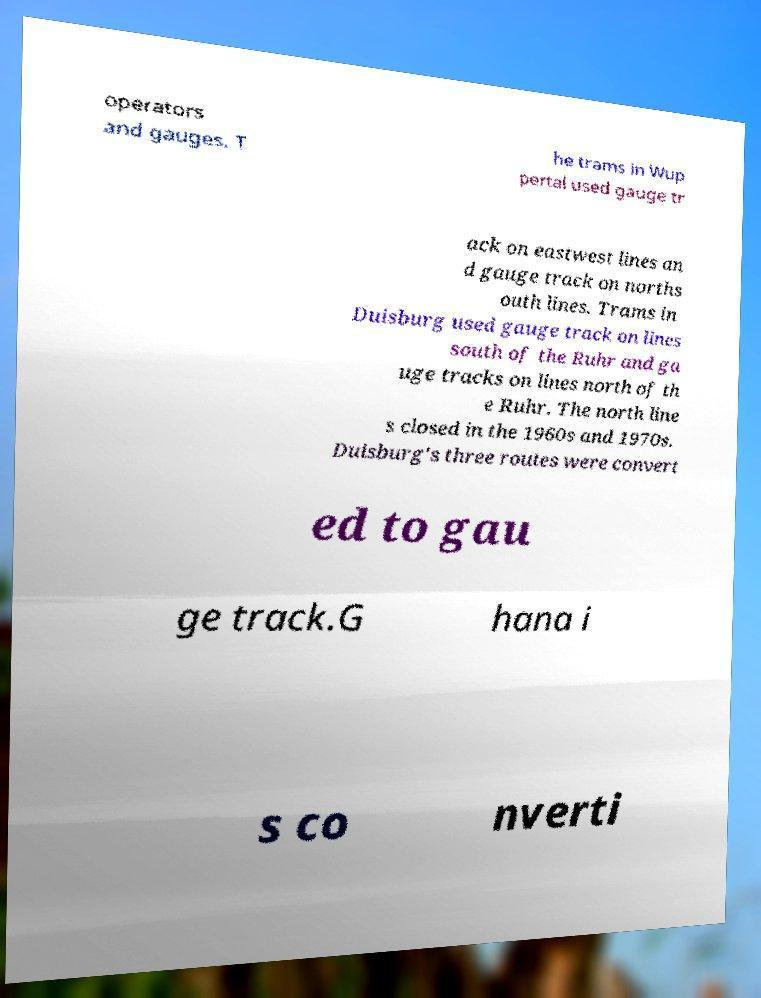Can you accurately transcribe the text from the provided image for me? operators and gauges. T he trams in Wup pertal used gauge tr ack on eastwest lines an d gauge track on norths outh lines. Trams in Duisburg used gauge track on lines south of the Ruhr and ga uge tracks on lines north of th e Ruhr. The north line s closed in the 1960s and 1970s. Duisburg's three routes were convert ed to gau ge track.G hana i s co nverti 